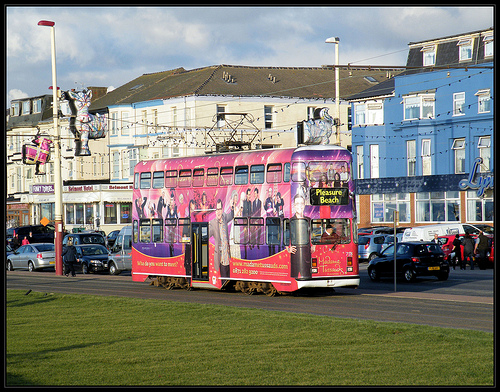<image>
Is there a window above the car? Yes. The window is positioned above the car in the vertical space, higher up in the scene. 